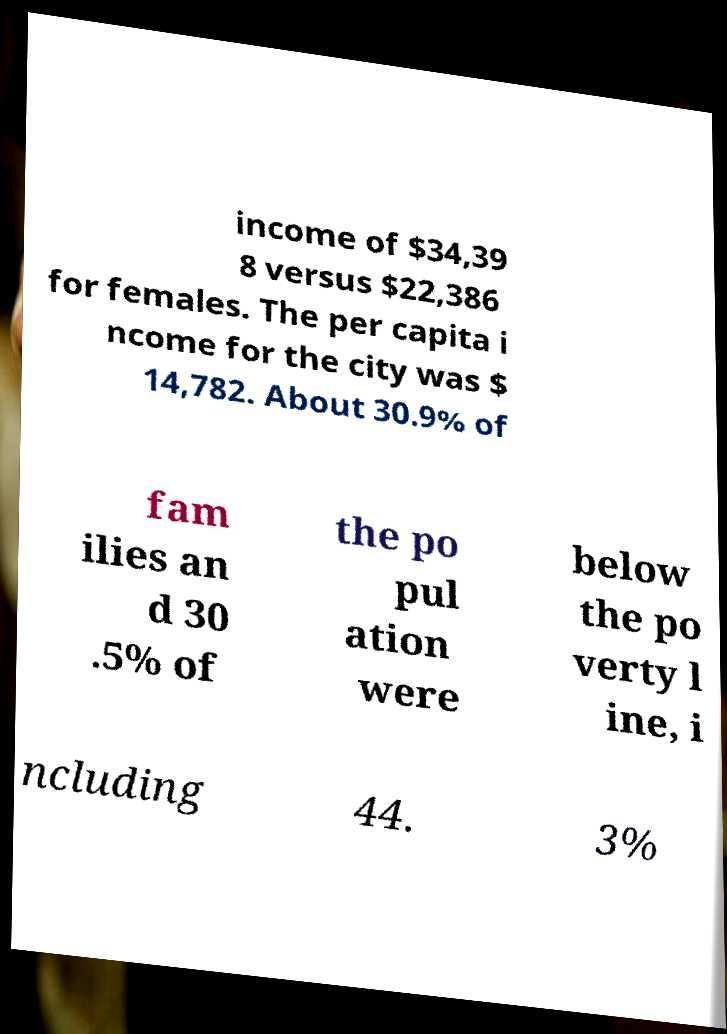Please read and relay the text visible in this image. What does it say? income of $34,39 8 versus $22,386 for females. The per capita i ncome for the city was $ 14,782. About 30.9% of fam ilies an d 30 .5% of the po pul ation were below the po verty l ine, i ncluding 44. 3% 